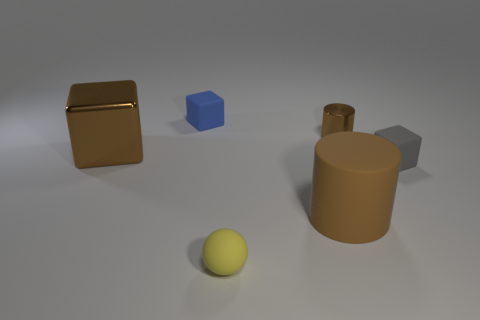There is another brown thing that is the same shape as the small brown object; what material is it?
Keep it short and to the point. Rubber. What number of blue things have the same size as the yellow ball?
Make the answer very short. 1. Do the brown cube and the blue rubber block have the same size?
Provide a succinct answer. No. What size is the object that is both in front of the tiny brown thing and behind the tiny gray object?
Your answer should be very brief. Large. Is the number of small matte objects that are behind the large metallic block greater than the number of big cylinders in front of the blue thing?
Make the answer very short. No. What color is the large shiny object that is the same shape as the tiny gray thing?
Offer a very short reply. Brown. Does the large object right of the large block have the same color as the small metallic object?
Your response must be concise. Yes. What number of small brown metallic objects are there?
Provide a short and direct response. 1. Does the small block that is on the left side of the small metal thing have the same material as the ball?
Offer a very short reply. Yes. Is there anything else that is the same material as the tiny yellow thing?
Ensure brevity in your answer.  Yes. 